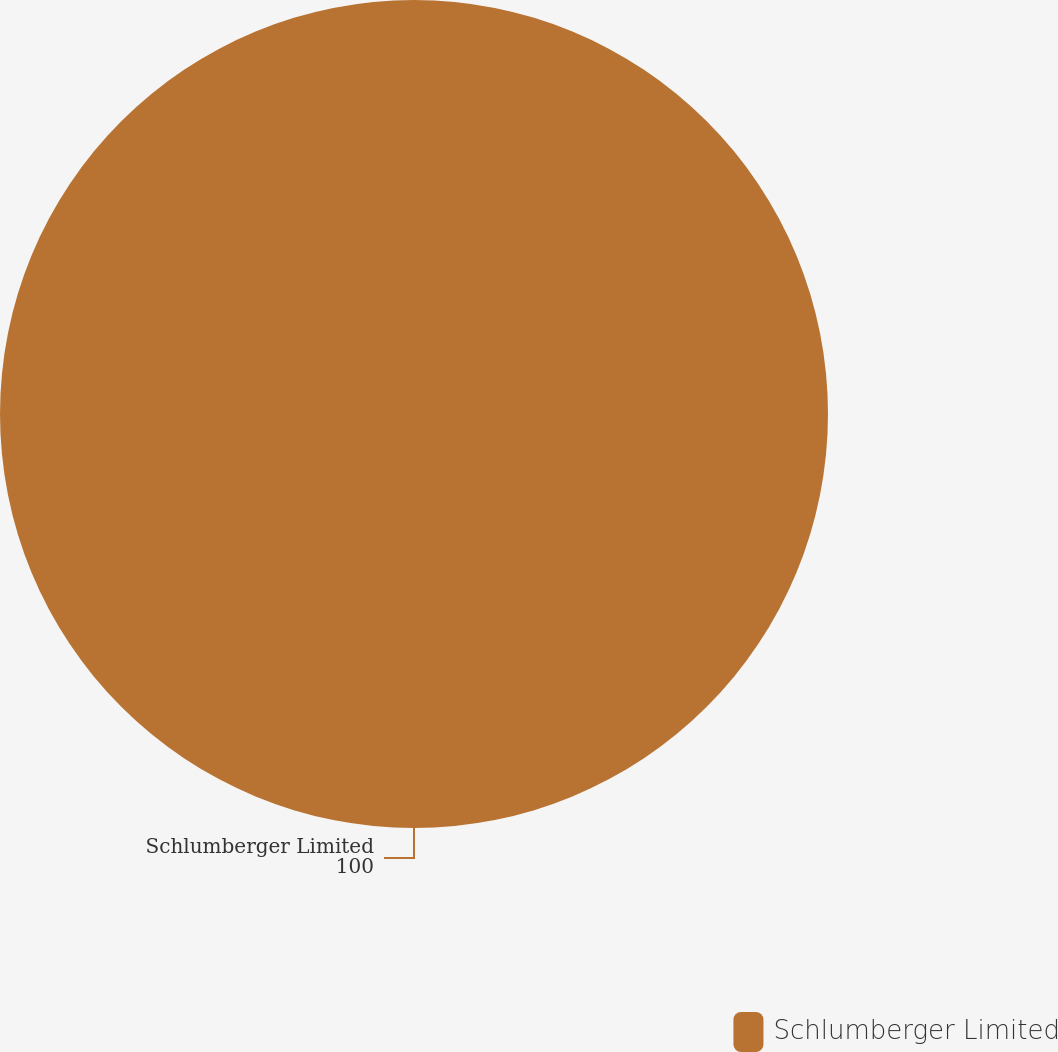Convert chart. <chart><loc_0><loc_0><loc_500><loc_500><pie_chart><fcel>Schlumberger Limited<nl><fcel>100.0%<nl></chart> 